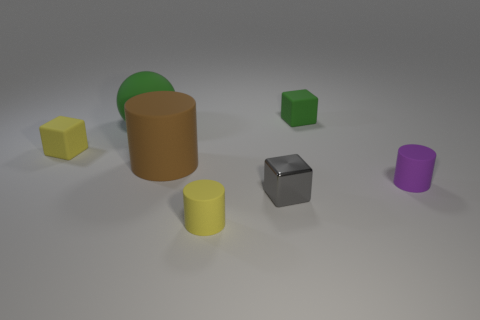Subtract 1 cylinders. How many cylinders are left? 2 Add 1 purple rubber cylinders. How many objects exist? 8 Subtract all balls. How many objects are left? 6 Subtract all yellow rubber blocks. Subtract all tiny cylinders. How many objects are left? 4 Add 5 small gray metal things. How many small gray metal things are left? 6 Add 3 purple matte cylinders. How many purple matte cylinders exist? 4 Subtract 0 red cylinders. How many objects are left? 7 